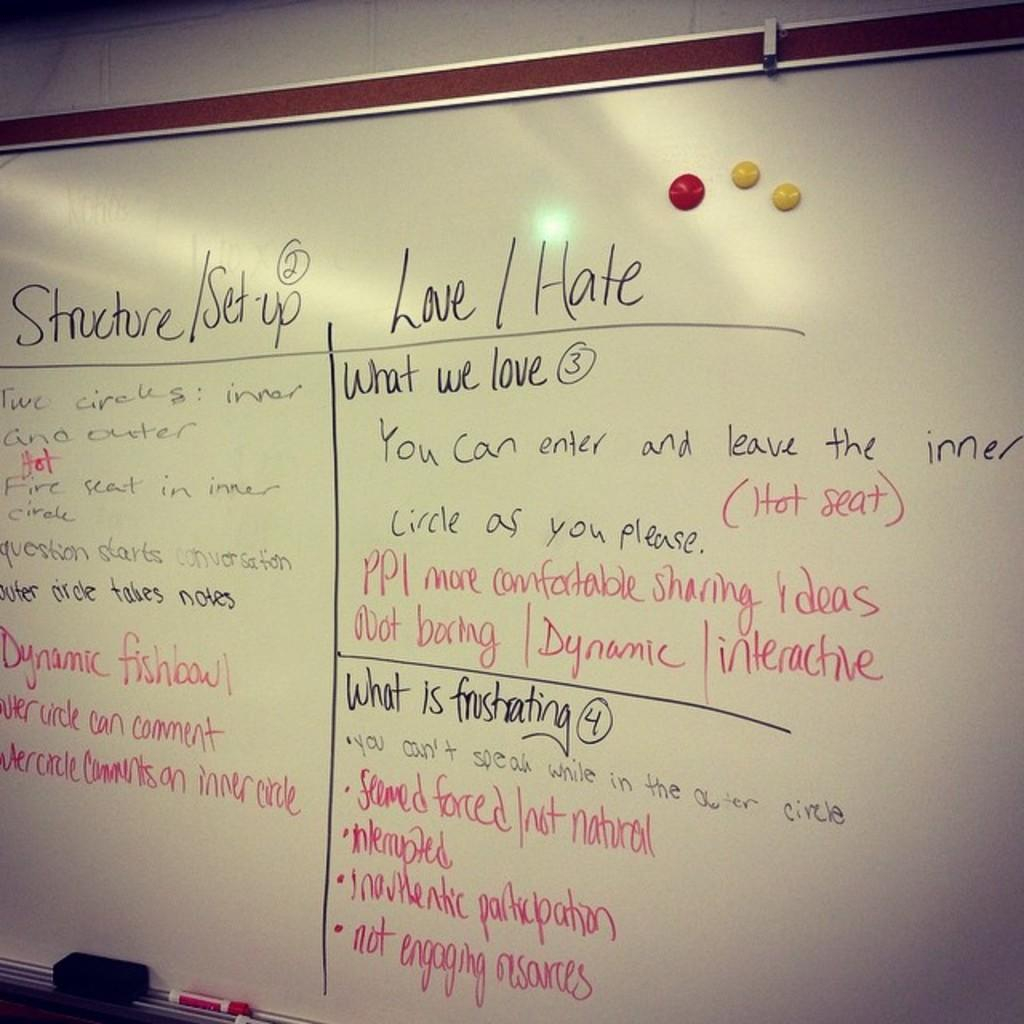<image>
Provide a brief description of the given image. A whiteboard with columns for what people love and what is frustrating 